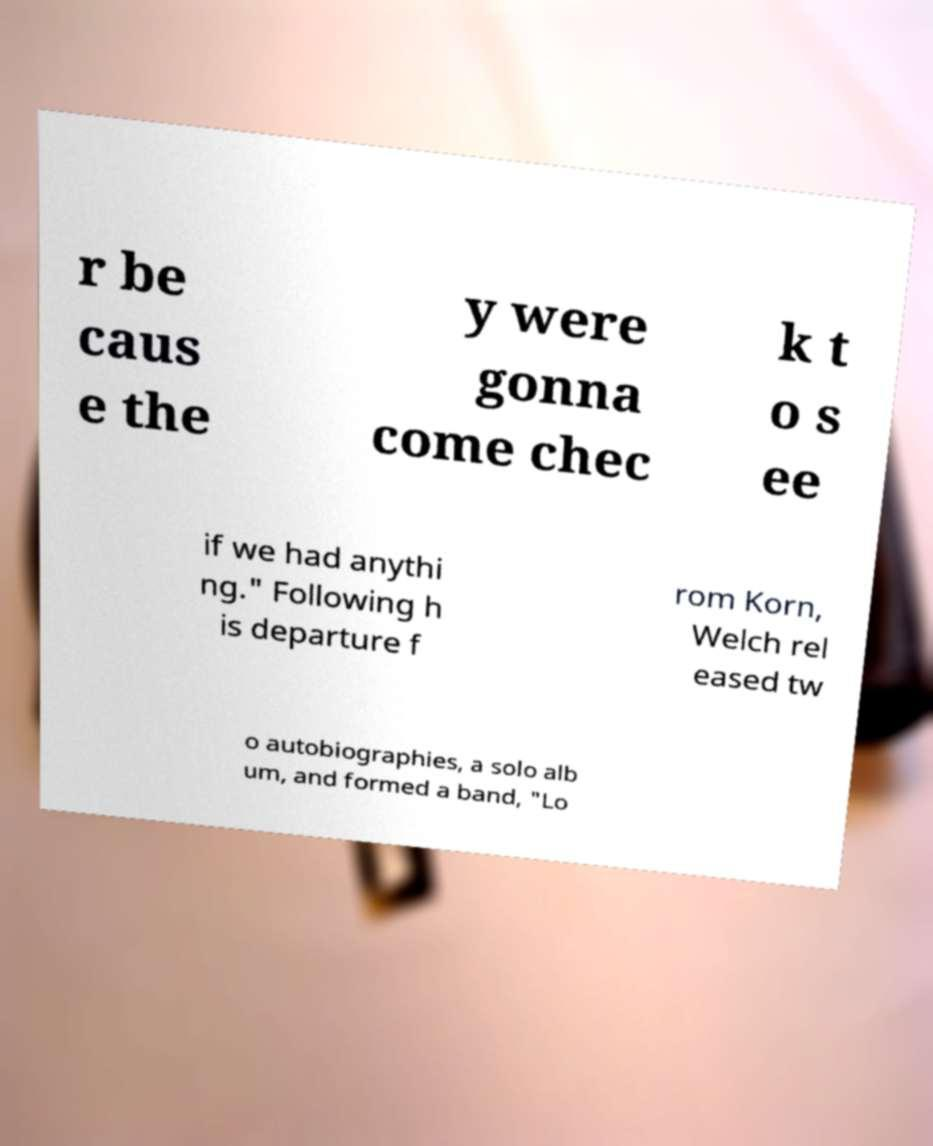Please identify and transcribe the text found in this image. r be caus e the y were gonna come chec k t o s ee if we had anythi ng." Following h is departure f rom Korn, Welch rel eased tw o autobiographies, a solo alb um, and formed a band, "Lo 